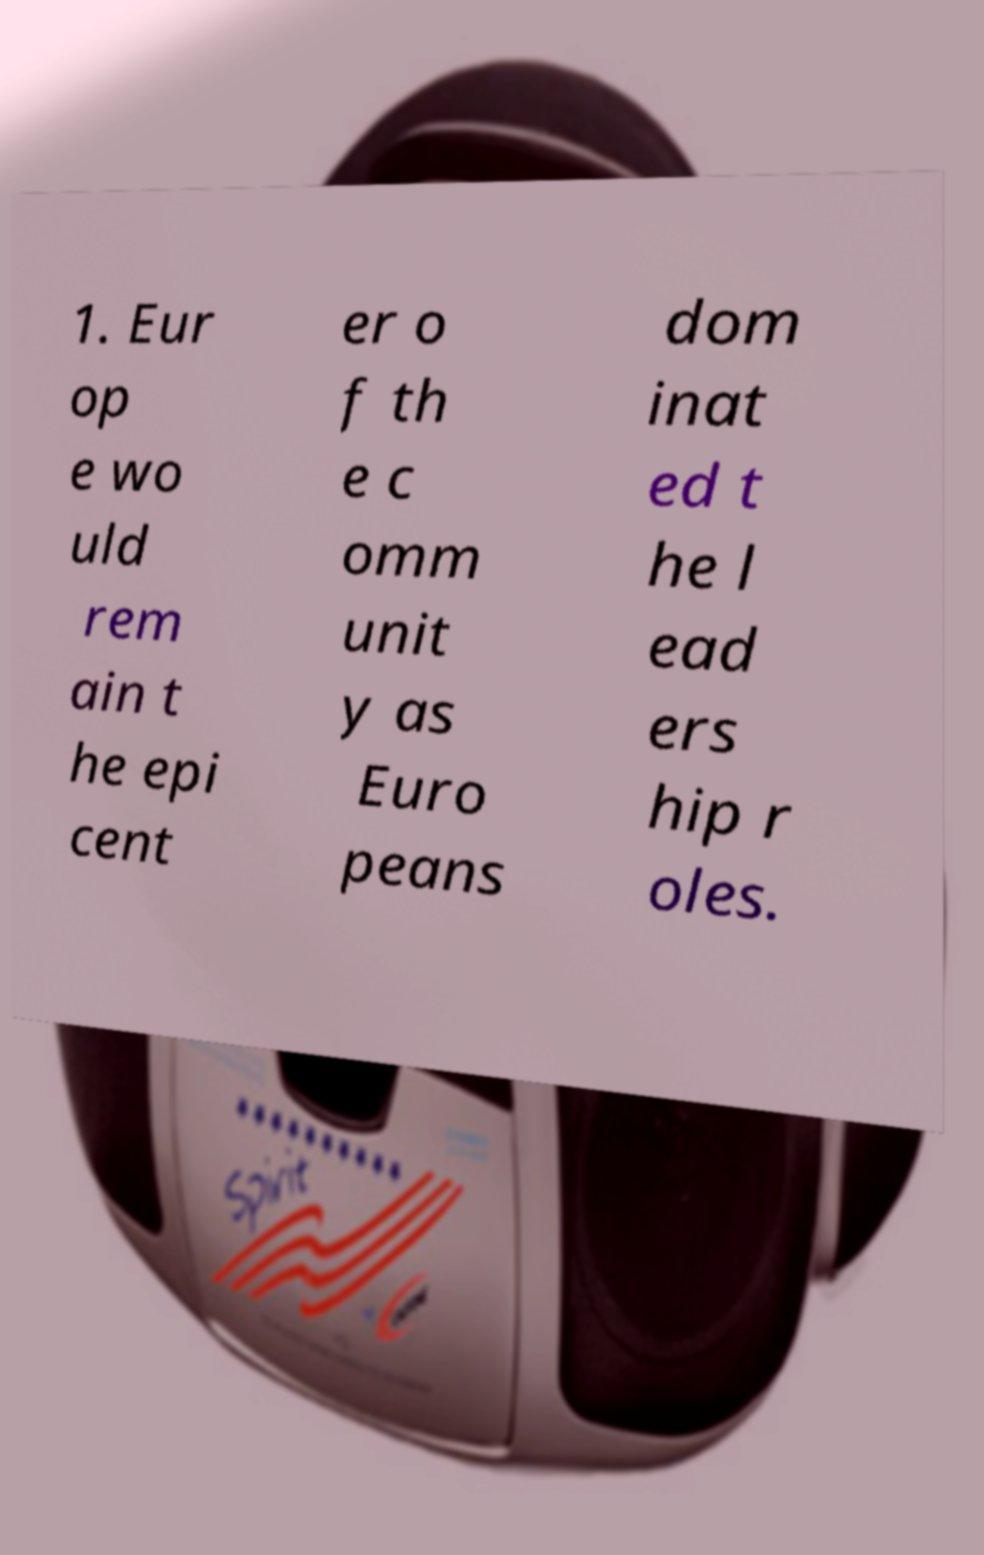For documentation purposes, I need the text within this image transcribed. Could you provide that? 1. Eur op e wo uld rem ain t he epi cent er o f th e c omm unit y as Euro peans dom inat ed t he l ead ers hip r oles. 